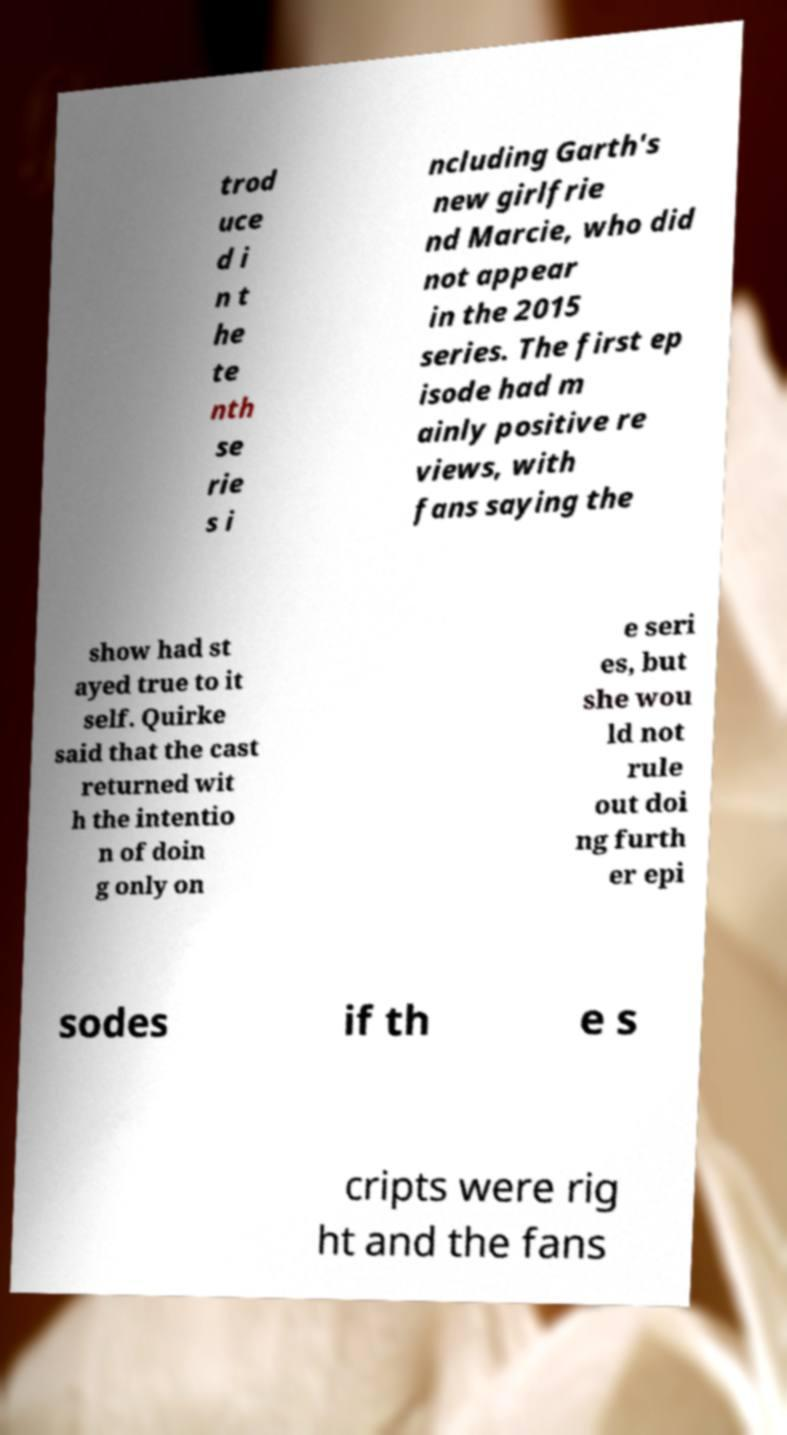Could you extract and type out the text from this image? trod uce d i n t he te nth se rie s i ncluding Garth's new girlfrie nd Marcie, who did not appear in the 2015 series. The first ep isode had m ainly positive re views, with fans saying the show had st ayed true to it self. Quirke said that the cast returned wit h the intentio n of doin g only on e seri es, but she wou ld not rule out doi ng furth er epi sodes if th e s cripts were rig ht and the fans 